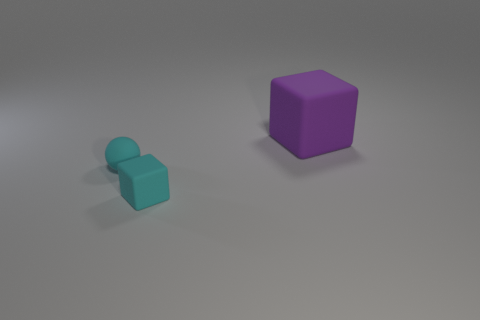Subtract all blocks. How many objects are left? 1 Subtract 1 blocks. How many blocks are left? 1 Add 3 cyan rubber balls. How many objects exist? 6 Subtract all purple blocks. Subtract all blue spheres. How many blocks are left? 1 Subtract all gray cubes. How many blue spheres are left? 0 Subtract all cyan matte things. Subtract all tiny cyan matte balls. How many objects are left? 0 Add 1 large purple rubber objects. How many large purple rubber objects are left? 2 Add 3 tiny cyan matte spheres. How many tiny cyan matte spheres exist? 4 Subtract 1 purple blocks. How many objects are left? 2 